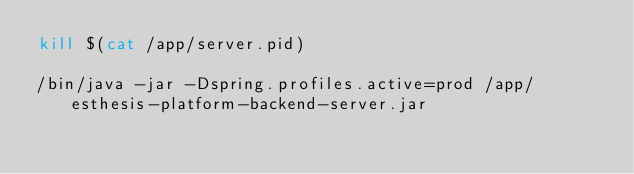<code> <loc_0><loc_0><loc_500><loc_500><_Bash_>kill $(cat /app/server.pid)

/bin/java -jar -Dspring.profiles.active=prod /app/esthesis-platform-backend-server.jar
</code> 